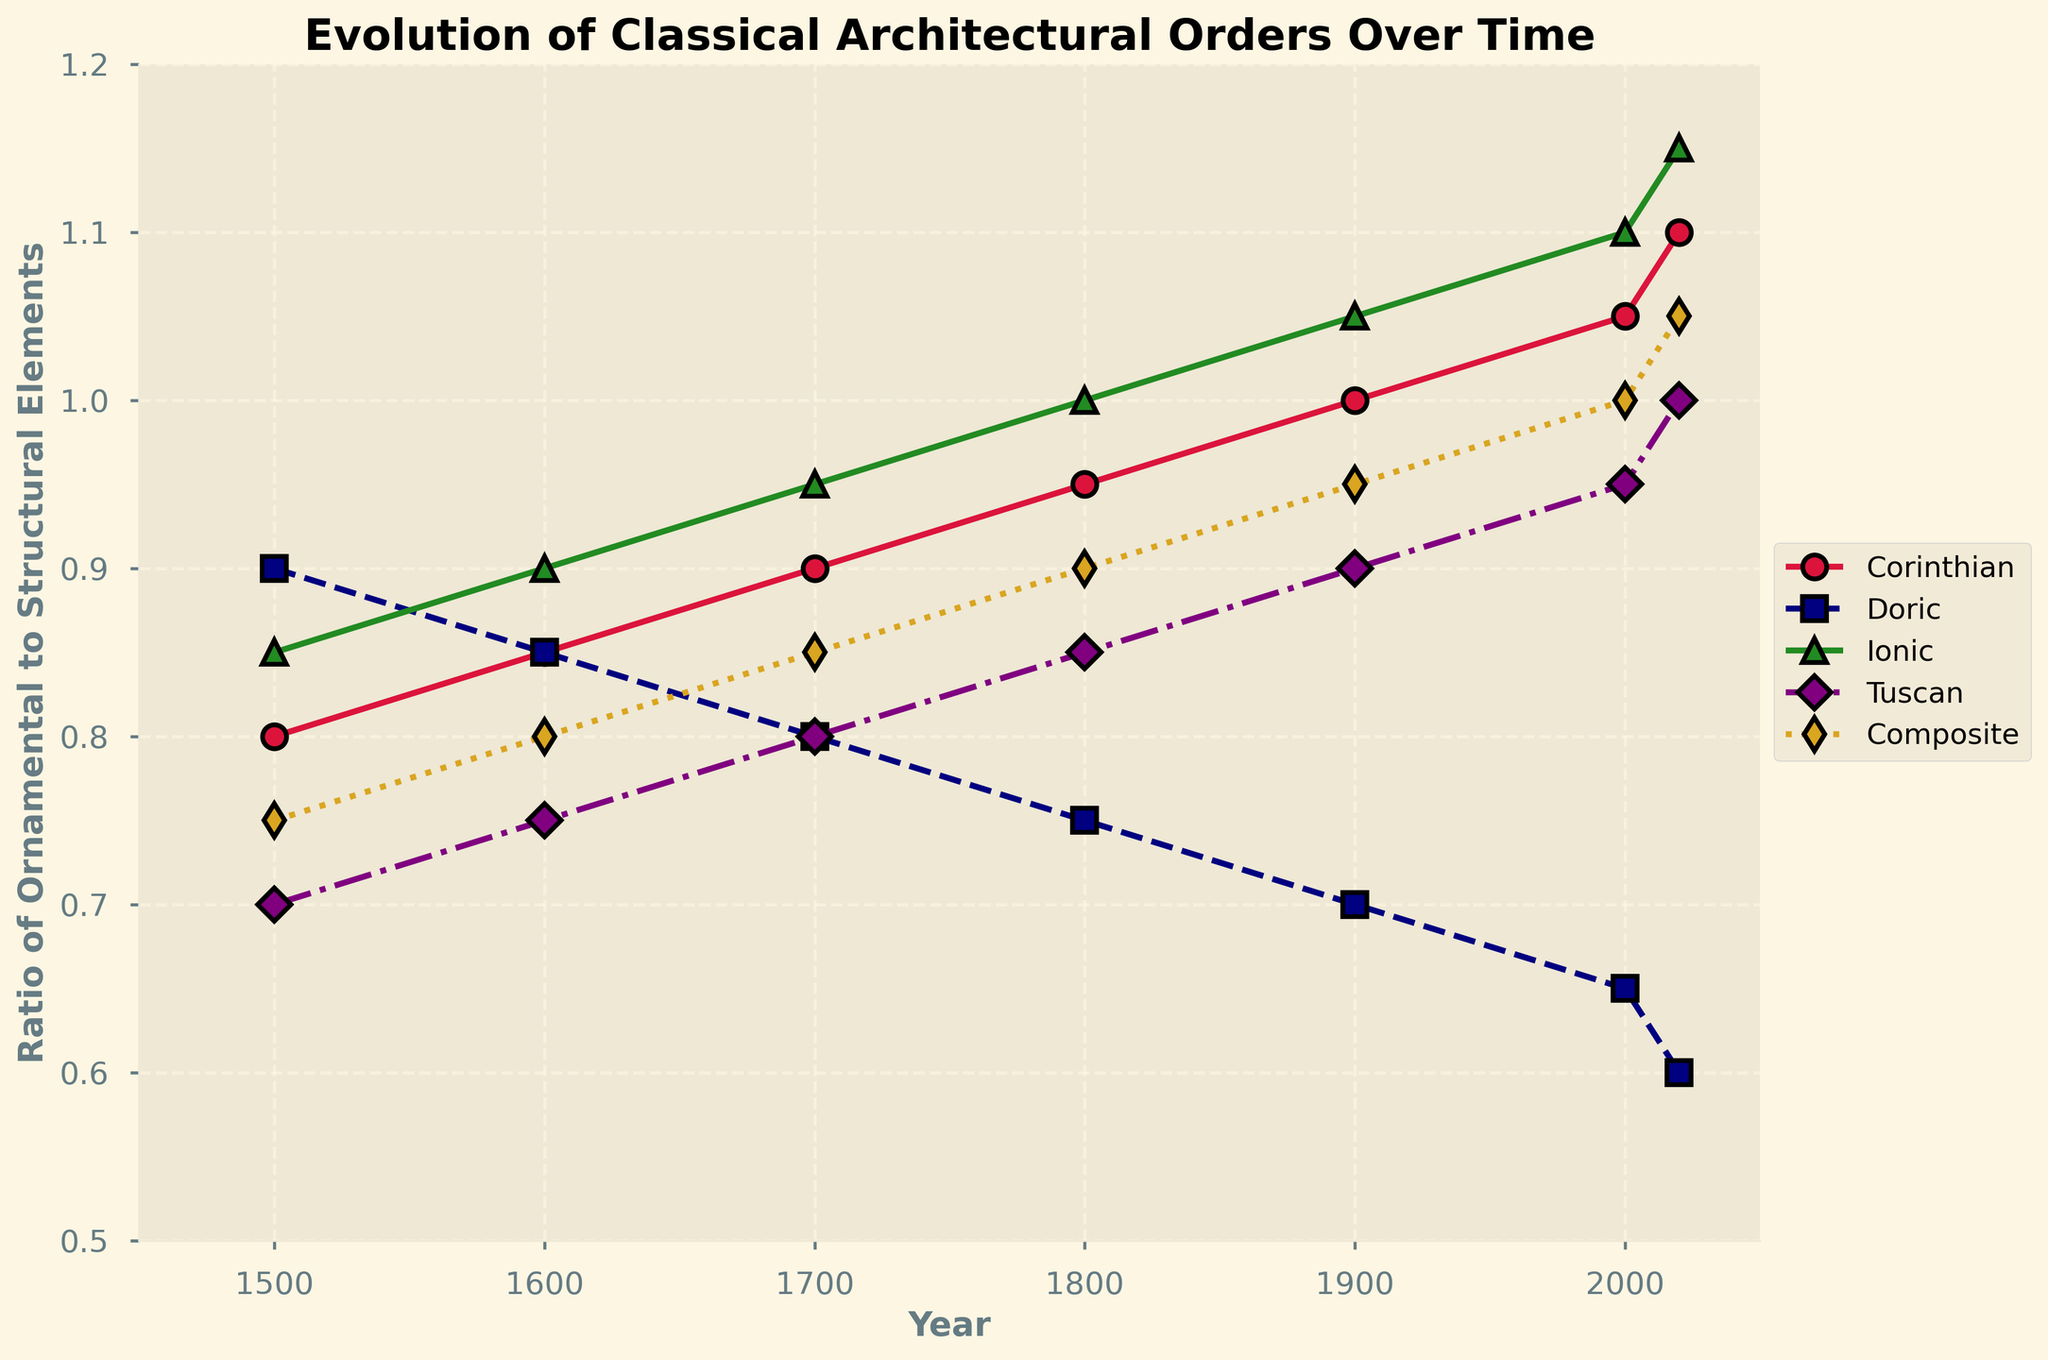What's the general trend of the Corinthian order over time? The Corinthian order consistently increases in the ratio of ornamental to structural elements from 1500 to 2020, starting at 0.8 and reaching 1.1.
Answer: Increasing Which architectural order has the most significant decline in the ratio of ornamental to structural elements from 1500 to 2020? The Doric order shows the most significant decline, starting at 0.9 in 1500 and decreasing to 0.6 in 2020.
Answer: Doric In which century does the Ionic order first surpass a ratio of 1.0? By examining the ratio values, the Ionic order surpasses 1.0 in the 1800s, specifically in 1800 with a value of 1.0 and continues to increase thereafter.
Answer: 1800s Compare the ratios of the Composite and Tuscan orders in the year 2000. Which order has a higher ratio, and by how much? In 2000, the Composite order has a ratio of 1.0, while the Tuscan order has a ratio of 0.95. The Composite order's ratio is higher by 0.05.
Answer: Composite; 0.05 Calculate the average ratio of the Doric order from 1500 to 2020. The values for Doric are 0.9 (1500), 0.85 (1600), 0.8 (1700), 0.75 (1800), 0.7 (1900), 0.65 (2000), and 0.6 (2020). The average is (0.9 + 0.85 + 0.8 + 0.75 + 0.7 + 0.65 + 0.6) / 7 = 0.75.
Answer: 0.75 Which architectural order shows the most significant increase in its ratio between 1500 and 2020? The Ionic order shows the most significant increase from 0.85 in 1500 to 1.15 in 2020, a difference of 0.3.
Answer: Ionic Identify the two orders that had the same ratio in 1600 and specify the shared ratio value. Both the Corinthian and Doric orders had a ratio of 0.85 in 1600.
Answer: Corinthian and Doric; 0.85 By how much did the Tuscan order's ratio increase from 1500 to 2020? The Tuscan order's ratio increased from 0.7 in 1500 to 1.0 in 2020, which is an increase of 0.3.
Answer: 0.3 In 2000, how many orders have a ratio of at least 1.0? In 2000, the Corinthian (1.05), Ionic (1.1), and Composite (1.0) orders have ratios of at least 1.0, making a total of three orders.
Answer: Three What is the trend for the Composite order from 1600 to 2000? The trend for the Composite order is an increasing ratio from 0.8 in 1600 to 1.0 in 2000.
Answer: Increasing 